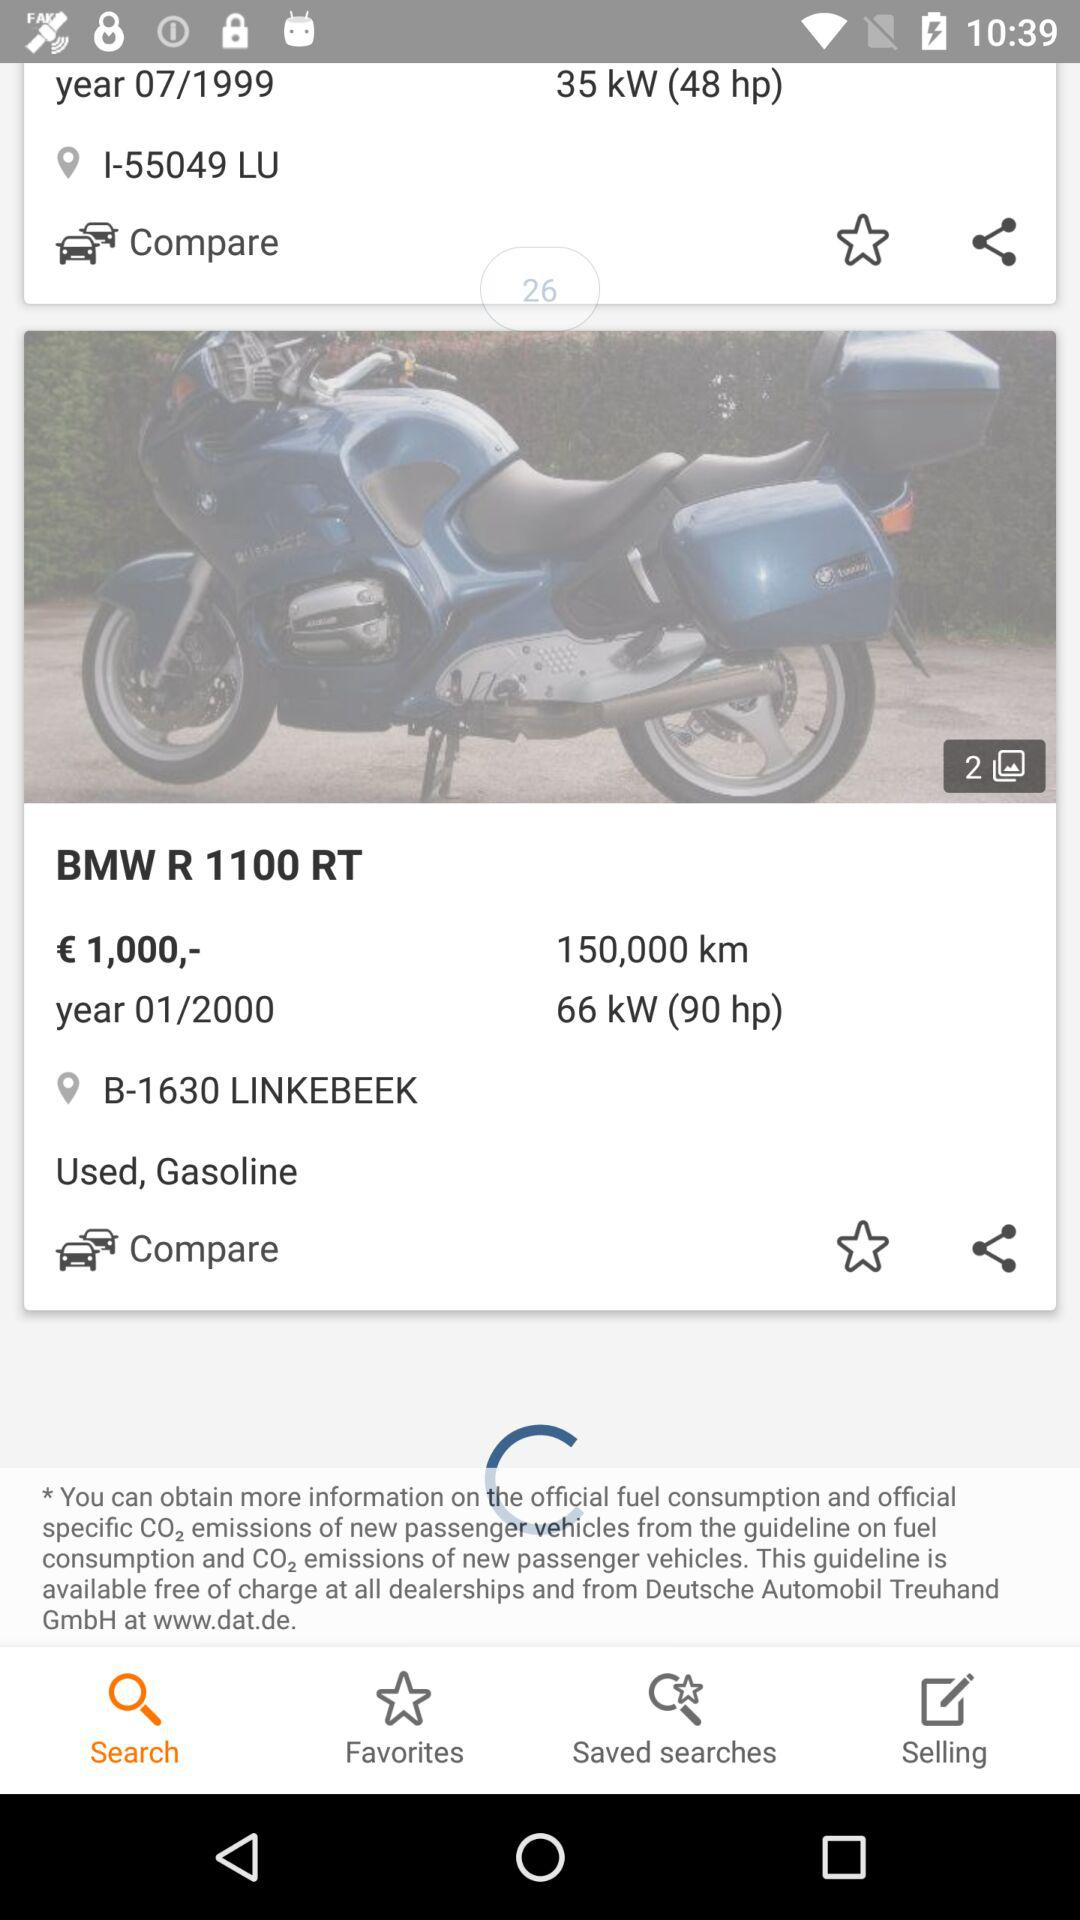What is the price of the "BMW R 1100 RT"? The price of the "BMW R 1100 RT" is €1,000. 